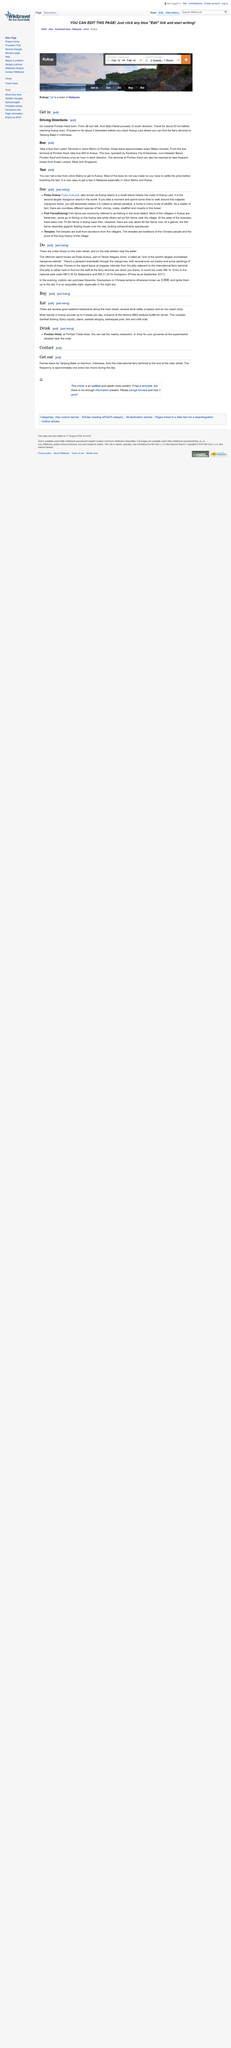Identify some key points in this picture. It is not the case that entering the national park is more expensive for Malaysians than for foreigners. Rather, the opposite is true. It is in fact more expensive for foreigners to enter the national park than for Malaysians. Most resorts in Kukup provide up to four meals per day, with many providing three meals per day, and some providing two meals per day. A round trip to Pulau Kakup costs RM 10. You should travel for approximately 2 kilometers before reaching Kukup Laut. It is advisable to take the bus from Larkin Terminal in Johor Bahru to Pontian, as it is the most convenient and efficient mode of transportation. 